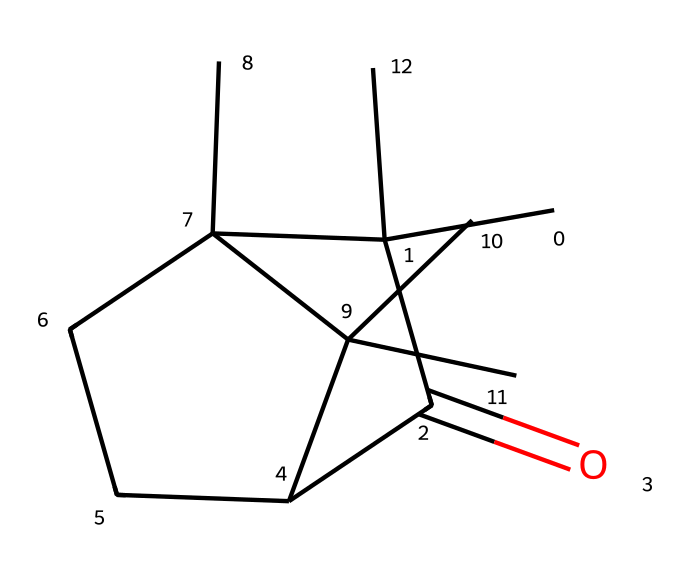What is the functional group present in camphor? The SMILES representation indicates the presence of a carbonyl group (C=O), characteristic of ketones, including camphor which specifically has this group as part of its structure.
Answer: carbonyl How many carbon atoms are in camphor? By analyzing the SMILES, we can count the 'C' characters and note that there are a total of 10 carbon atoms in the structure of camphor.
Answer: 10 What type of compound is camphor classified as? The presence of the carbonyl group and specific structural features indicate that camphor is classified as a ketone, due to its functional group and molecular characteristics.
Answer: ketone How many rings are present in the structure of camphor? The SMILES notation shows the presence of two 'C' connected rings in the bicyclic structure, indicating that camphor has two rings in its molecular structure.
Answer: 2 What is the total number of oxygen atoms in camphor? The SMILES representation shows a single 'O' in the structure, indicating there is one oxygen atom present in camphor.
Answer: 1 What is the saturation level of camphor? Given the presence of a carbonyl group and the number of carbon-carbon bonds, camphor is unsaturated due to the double bond in the carbonyl group, suggesting one unsaturation in the compound.
Answer: unsaturated How many branches are found in camphor? The structural complexity observed in the SMILES indicates there are multiple substituent groups branching off the central carbon skeleton, leading to a total of four branches in camphor's structure.
Answer: 4 